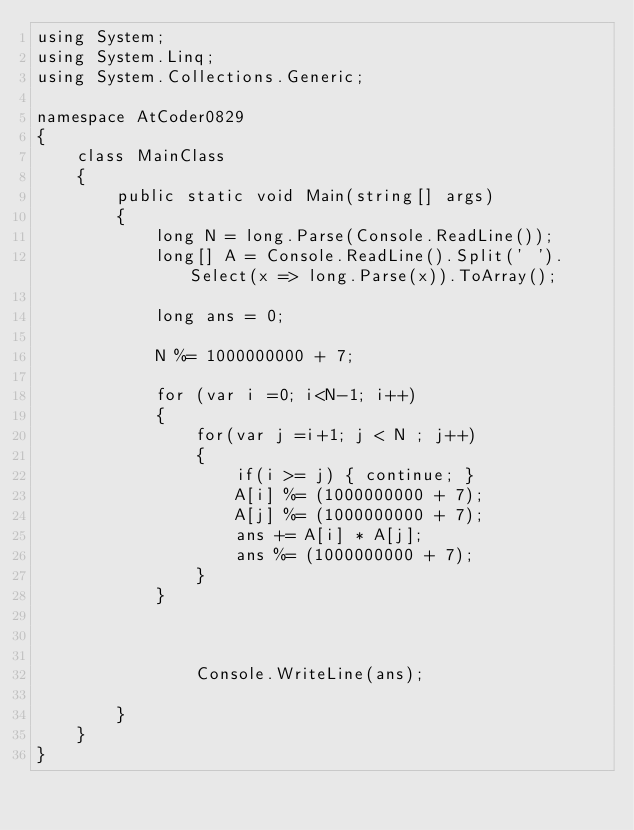Convert code to text. <code><loc_0><loc_0><loc_500><loc_500><_C#_>using System;
using System.Linq;
using System.Collections.Generic;

namespace AtCoder0829
{
    class MainClass
    {
        public static void Main(string[] args)
        {
            long N = long.Parse(Console.ReadLine());
            long[] A = Console.ReadLine().Split(' ').Select(x => long.Parse(x)).ToArray();

            long ans = 0;

            N %= 1000000000 + 7;

            for (var i =0; i<N-1; i++)
            {
                for(var j =i+1; j < N ; j++)
                {
                    if(i >= j) { continue; }
                    A[i] %= (1000000000 + 7);
                    A[j] %= (1000000000 + 7);
                    ans += A[i] * A[j];
                    ans %= (1000000000 + 7);
                }
            }



                Console.WriteLine(ans);
            
        }
    }
}

</code> 